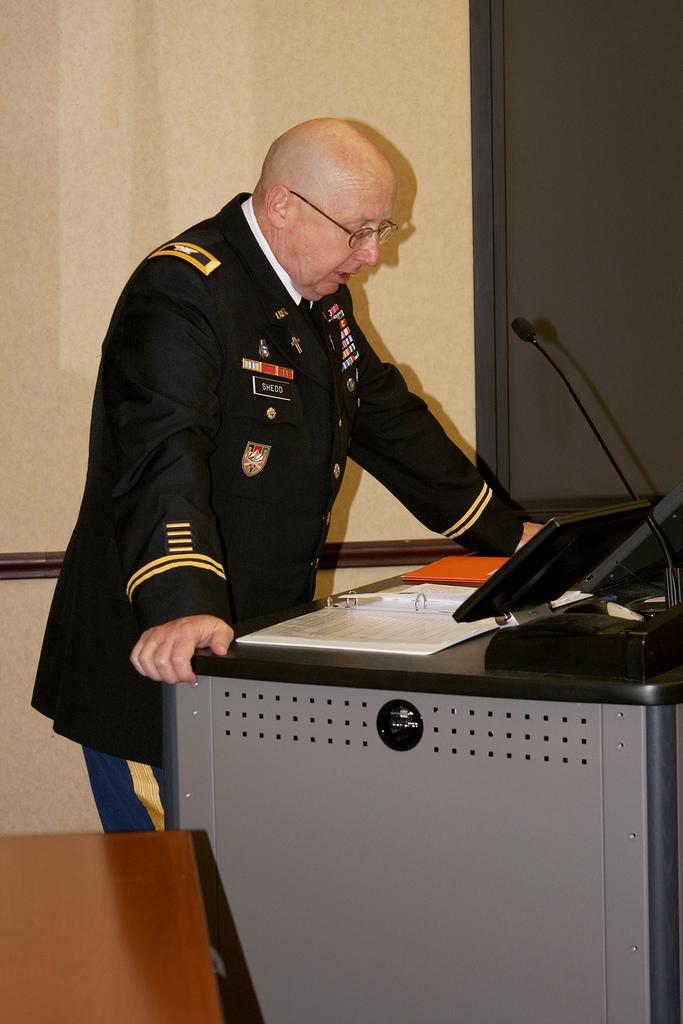What is the man in the image doing? The man is standing in the image. What is on the table in the image? There is a monitor, a microphone, and papers on the table. What is the man wearing in the image? The man is wearing a uniform. What type of furniture is present in the image? There is a table and a chair in the image. What is the background of the image? There is a wall in the image. Is there a cord visible in the image that the man is using to burn something? No, there is no cord visible in the image, and the man is not burning anything. Can you see an argument taking place between the man and someone else in the image? No, there is no argument visible in the image. 